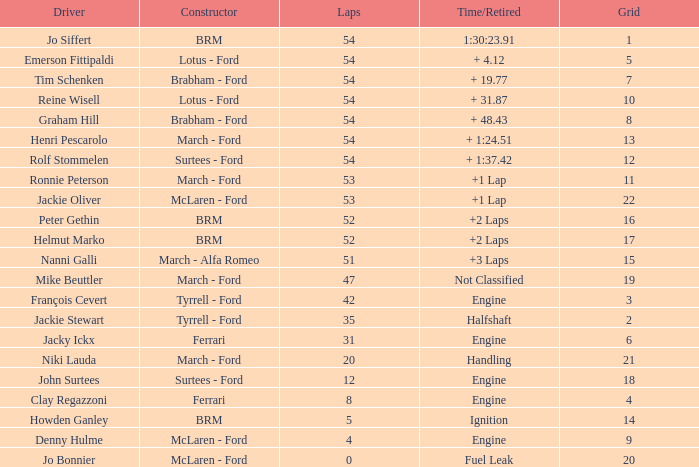What is the standard grid that has in excess of 8 laps, a time/retired greater than 2 laps, and features peter gethin driving? 16.0. 